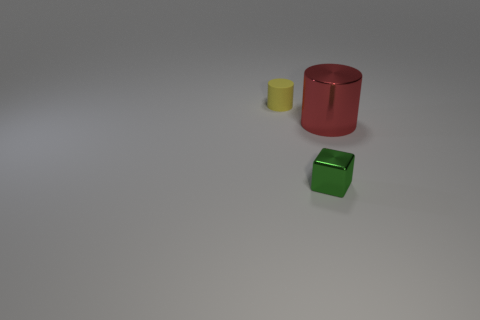How do the objects relate to each other in terms of size? In relation to size, the red metal cylinder is the tallest among the displayed objects. The yellow cylinder is shorter and has a smaller diameter compared to the red one. The green cube, with distinct edges, is smaller in height than the two cylinders and its square base provides a shape contrast. If one were to stack the yellow cylinder atop the green cube, they might approach the height of the red cylinder, which stands alone as the most prominent object in terms of size. 